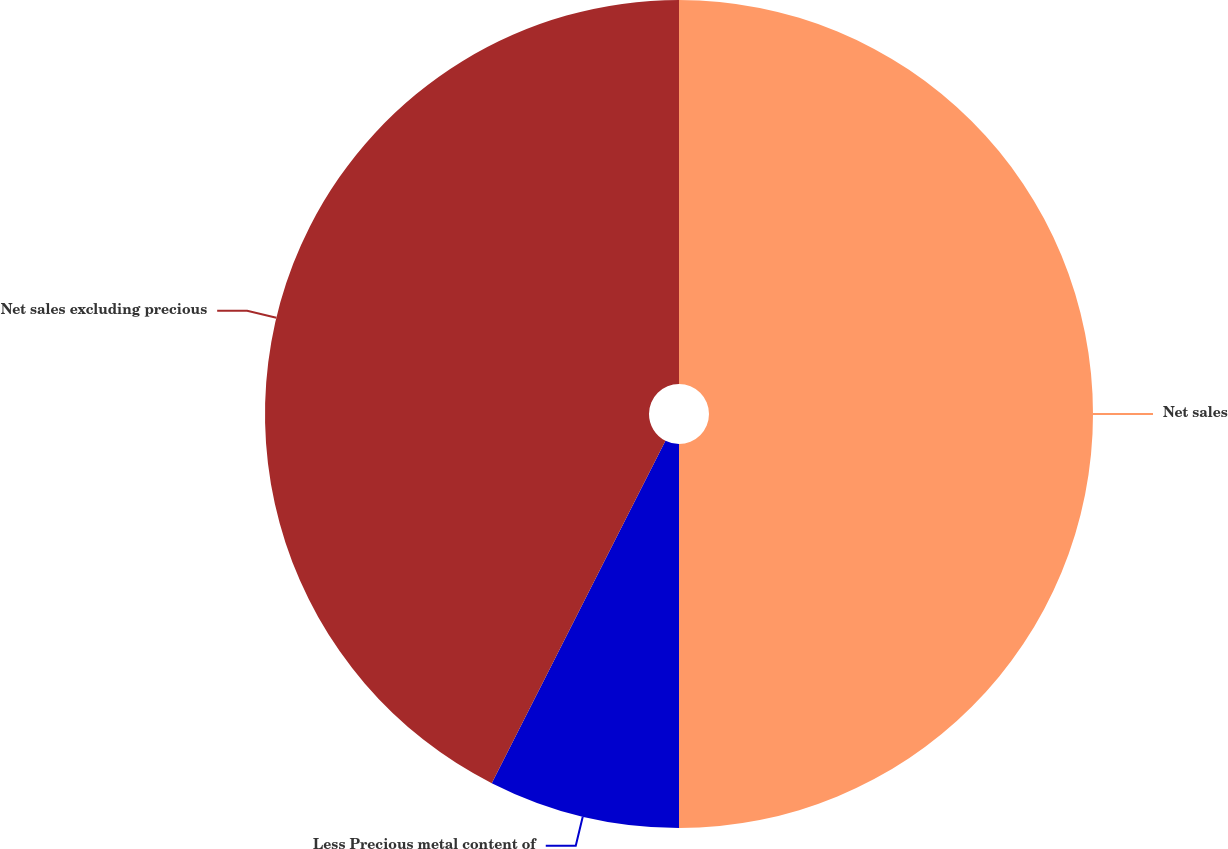Convert chart to OTSL. <chart><loc_0><loc_0><loc_500><loc_500><pie_chart><fcel>Net sales<fcel>Less Precious metal content of<fcel>Net sales excluding precious<nl><fcel>50.0%<fcel>7.47%<fcel>42.53%<nl></chart> 